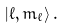<formula> <loc_0><loc_0><loc_500><loc_500>\left | \ell , m _ { \ell } \right > .</formula> 